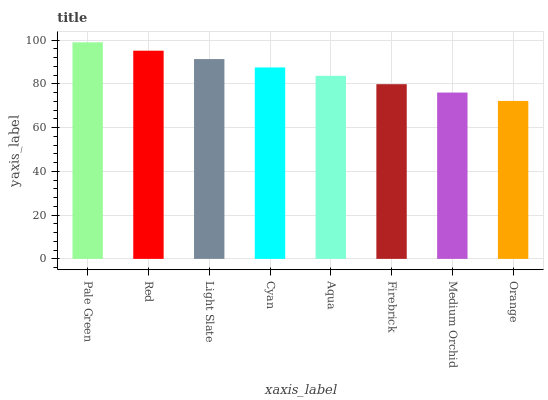Is Orange the minimum?
Answer yes or no. Yes. Is Pale Green the maximum?
Answer yes or no. Yes. Is Red the minimum?
Answer yes or no. No. Is Red the maximum?
Answer yes or no. No. Is Pale Green greater than Red?
Answer yes or no. Yes. Is Red less than Pale Green?
Answer yes or no. Yes. Is Red greater than Pale Green?
Answer yes or no. No. Is Pale Green less than Red?
Answer yes or no. No. Is Cyan the high median?
Answer yes or no. Yes. Is Aqua the low median?
Answer yes or no. Yes. Is Firebrick the high median?
Answer yes or no. No. Is Medium Orchid the low median?
Answer yes or no. No. 